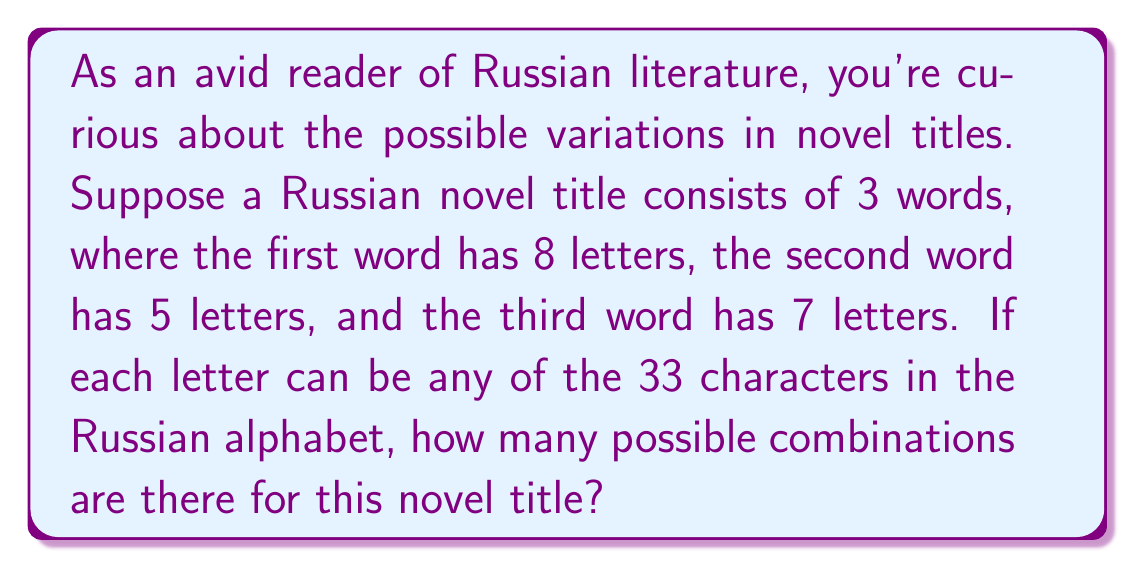Give your solution to this math problem. Let's approach this step-by-step:

1) In the Russian alphabet, there are 33 characters.

2) For each letter position, we have 33 choices.

3) For the first word (8 letters):
   $$ 33^8 \text{ combinations} $$

4) For the second word (5 letters):
   $$ 33^5 \text{ combinations} $$

5) For the third word (7 letters):
   $$ 33^7 \text{ combinations} $$

6) According to the multiplication principle, when we have independent events, we multiply their individual probabilities to get the total number of possible outcomes.

7) Therefore, the total number of possible combinations is:
   $$ 33^8 \times 33^5 \times 33^7 $$

8) This can be simplified as:
   $$ 33^{8+5+7} = 33^{20} $$

9) Calculate:
   $$ 33^{20} = 1.2089258196146292e+30 $$
Answer: The number of possible character combinations for the Russian novel title is $33^{20}$ or approximately $1.21 \times 10^{30}$. 